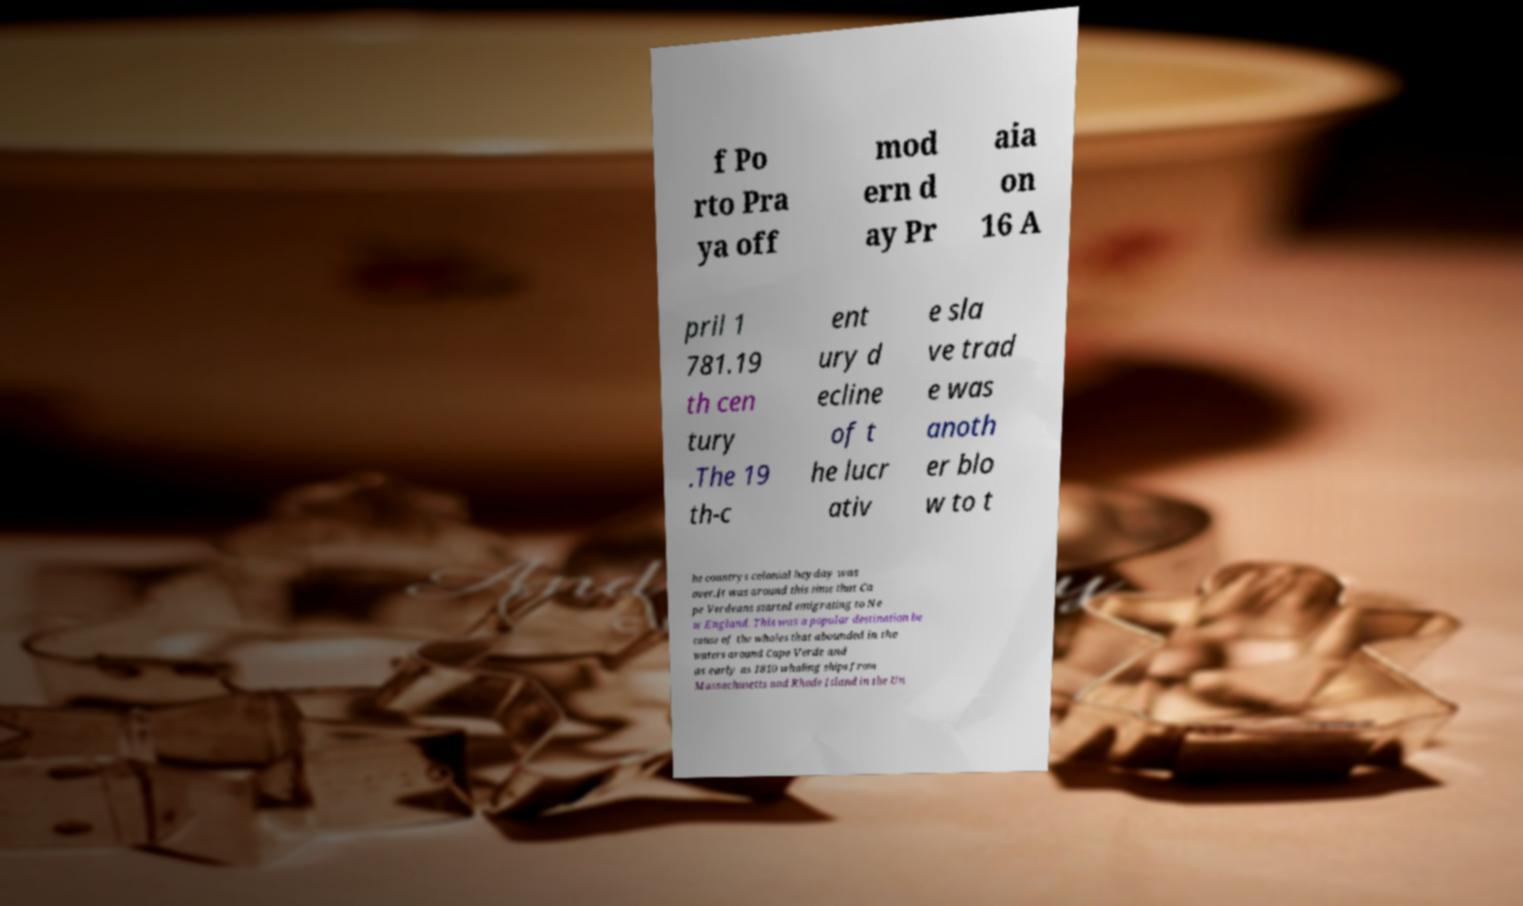There's text embedded in this image that I need extracted. Can you transcribe it verbatim? f Po rto Pra ya off mod ern d ay Pr aia on 16 A pril 1 781.19 th cen tury .The 19 th-c ent ury d ecline of t he lucr ativ e sla ve trad e was anoth er blo w to t he countrys colonial heyday was over.It was around this time that Ca pe Verdeans started emigrating to Ne w England. This was a popular destination be cause of the whales that abounded in the waters around Cape Verde and as early as 1810 whaling ships from Massachusetts and Rhode Island in the Un 